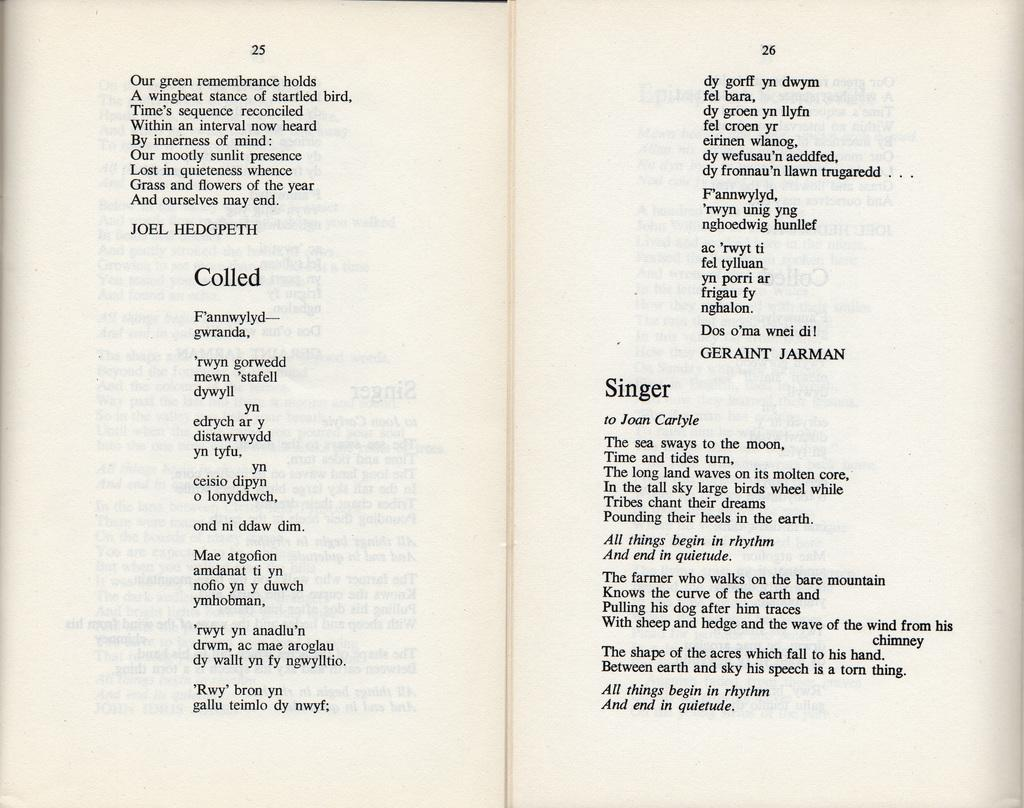<image>
Offer a succinct explanation of the picture presented. An opened book of poetry with selections named "Colled" and "Singer" 